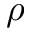Convert formula to latex. <formula><loc_0><loc_0><loc_500><loc_500>\rho</formula> 